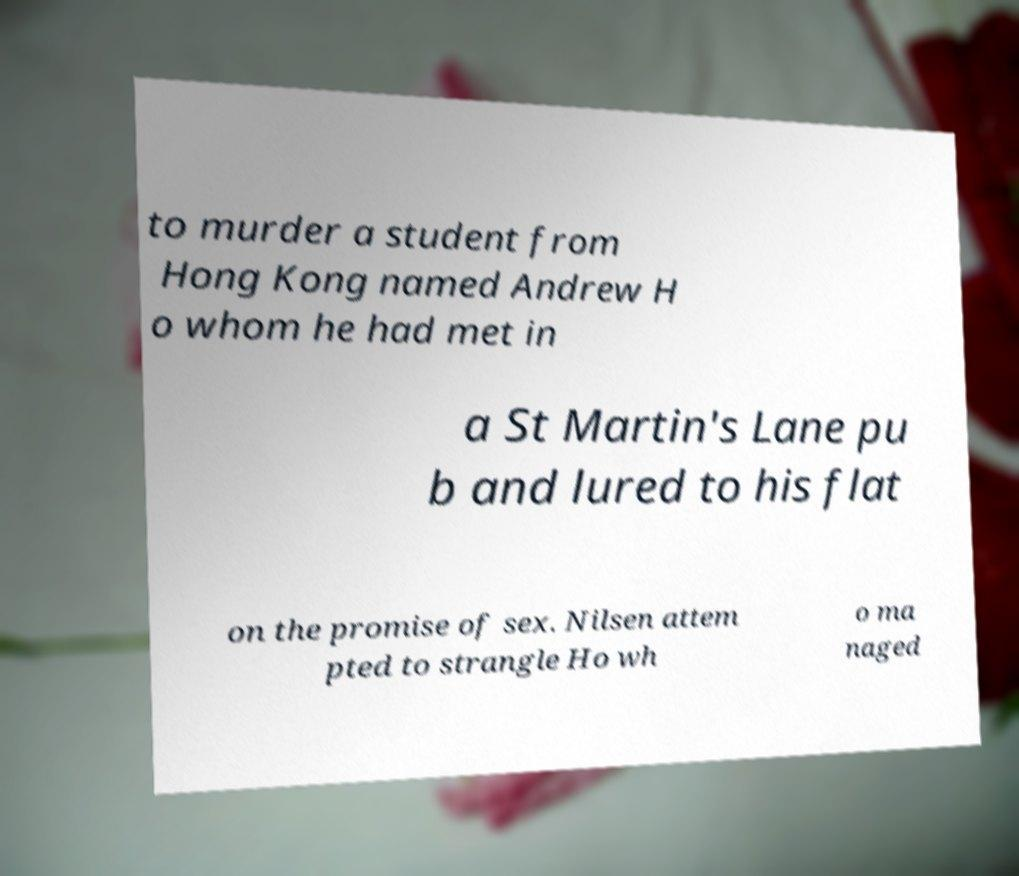For documentation purposes, I need the text within this image transcribed. Could you provide that? to murder a student from Hong Kong named Andrew H o whom he had met in a St Martin's Lane pu b and lured to his flat on the promise of sex. Nilsen attem pted to strangle Ho wh o ma naged 